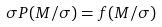Convert formula to latex. <formula><loc_0><loc_0><loc_500><loc_500>\sigma P ( { M / \sigma } ) = f ( { M / \sigma } )</formula> 